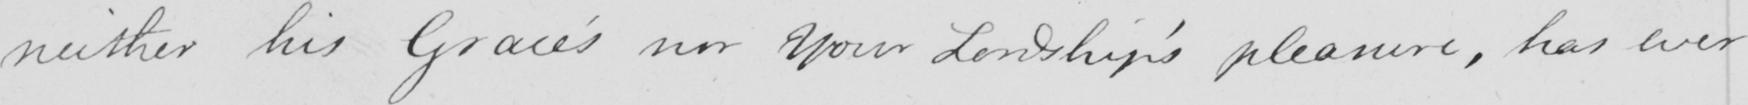Can you read and transcribe this handwriting? neither his Grace ' s nor your Lordship ' s pleasure , has ever 